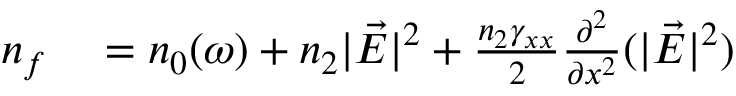Convert formula to latex. <formula><loc_0><loc_0><loc_500><loc_500>\begin{array} { r l } { n _ { f } } & = n _ { 0 } ( \omega ) + n _ { 2 } | \vec { E } | ^ { 2 } + \frac { n _ { 2 } \gamma _ { x x } } { 2 } \frac { \partial ^ { 2 } } { \partial x ^ { 2 } } ( | \vec { E } | ^ { 2 } ) } \end{array}</formula> 